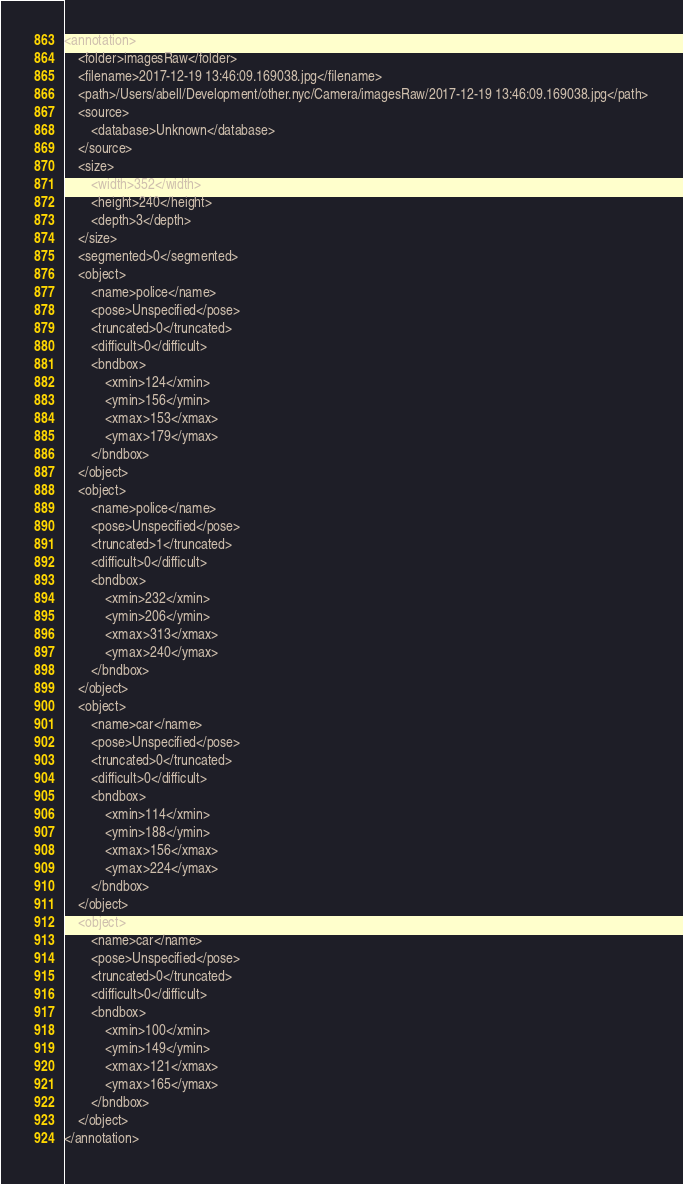<code> <loc_0><loc_0><loc_500><loc_500><_XML_><annotation>
	<folder>imagesRaw</folder>
	<filename>2017-12-19 13:46:09.169038.jpg</filename>
	<path>/Users/abell/Development/other.nyc/Camera/imagesRaw/2017-12-19 13:46:09.169038.jpg</path>
	<source>
		<database>Unknown</database>
	</source>
	<size>
		<width>352</width>
		<height>240</height>
		<depth>3</depth>
	</size>
	<segmented>0</segmented>
	<object>
		<name>police</name>
		<pose>Unspecified</pose>
		<truncated>0</truncated>
		<difficult>0</difficult>
		<bndbox>
			<xmin>124</xmin>
			<ymin>156</ymin>
			<xmax>153</xmax>
			<ymax>179</ymax>
		</bndbox>
	</object>
	<object>
		<name>police</name>
		<pose>Unspecified</pose>
		<truncated>1</truncated>
		<difficult>0</difficult>
		<bndbox>
			<xmin>232</xmin>
			<ymin>206</ymin>
			<xmax>313</xmax>
			<ymax>240</ymax>
		</bndbox>
	</object>
	<object>
		<name>car</name>
		<pose>Unspecified</pose>
		<truncated>0</truncated>
		<difficult>0</difficult>
		<bndbox>
			<xmin>114</xmin>
			<ymin>188</ymin>
			<xmax>156</xmax>
			<ymax>224</ymax>
		</bndbox>
	</object>
	<object>
		<name>car</name>
		<pose>Unspecified</pose>
		<truncated>0</truncated>
		<difficult>0</difficult>
		<bndbox>
			<xmin>100</xmin>
			<ymin>149</ymin>
			<xmax>121</xmax>
			<ymax>165</ymax>
		</bndbox>
	</object>
</annotation>
</code> 